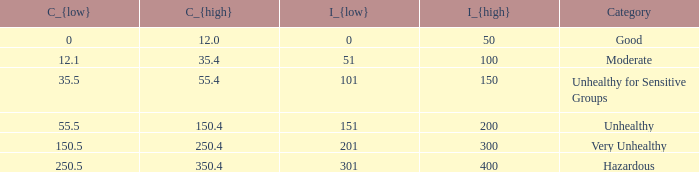What's the C_{high} when the C_{low} value is 250.5? 350.4. 